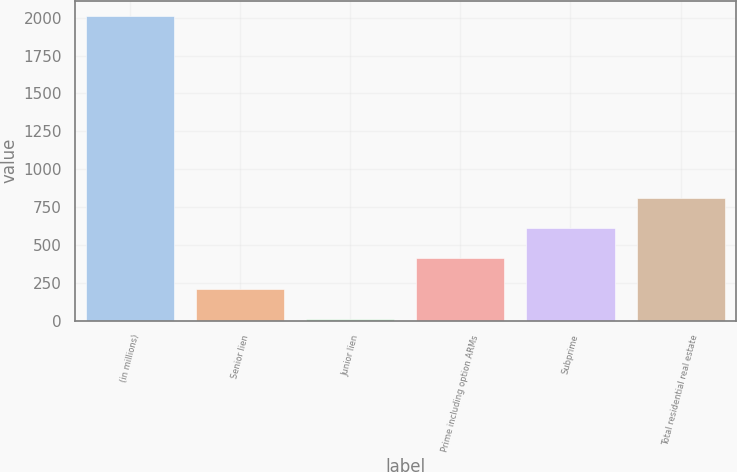Convert chart to OTSL. <chart><loc_0><loc_0><loc_500><loc_500><bar_chart><fcel>(in millions)<fcel>Senior lien<fcel>Junior lien<fcel>Prime including option ARMs<fcel>Subprime<fcel>Total residential real estate<nl><fcel>2010<fcel>210<fcel>10<fcel>410<fcel>610<fcel>810<nl></chart> 